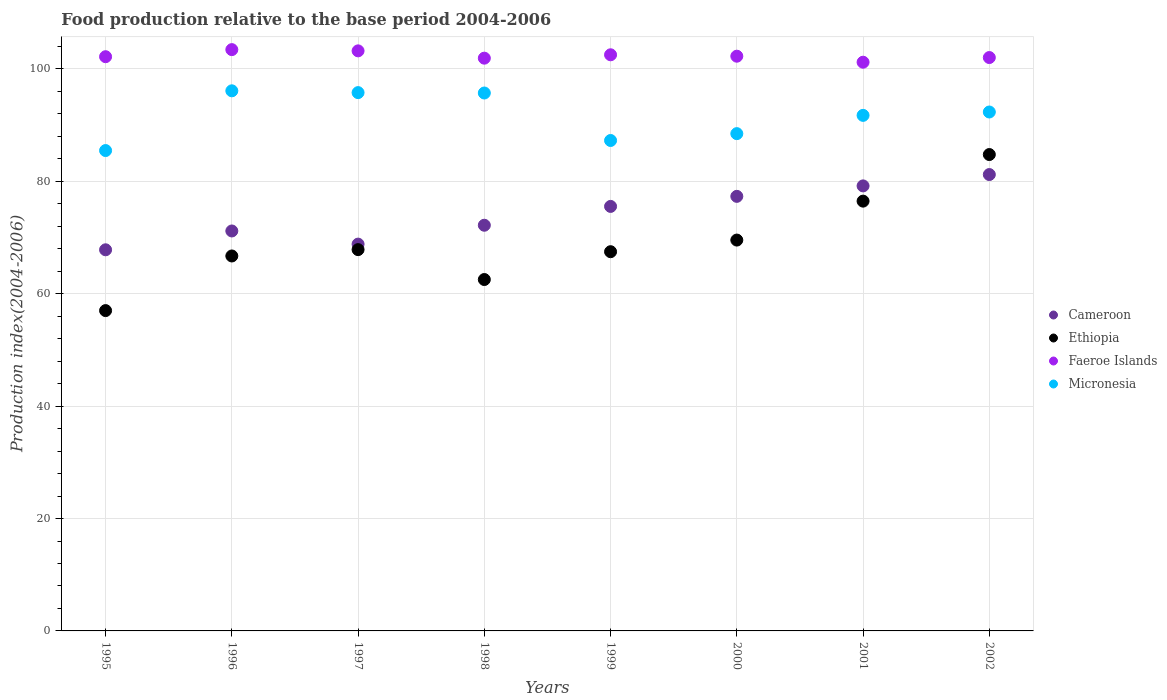Is the number of dotlines equal to the number of legend labels?
Offer a very short reply. Yes. What is the food production index in Faeroe Islands in 2002?
Offer a very short reply. 102.03. Across all years, what is the maximum food production index in Micronesia?
Your response must be concise. 96.11. Across all years, what is the minimum food production index in Micronesia?
Ensure brevity in your answer.  85.48. In which year was the food production index in Micronesia maximum?
Provide a short and direct response. 1996. In which year was the food production index in Faeroe Islands minimum?
Your response must be concise. 2001. What is the total food production index in Faeroe Islands in the graph?
Make the answer very short. 818.78. What is the difference between the food production index in Faeroe Islands in 1995 and that in 1998?
Keep it short and to the point. 0.26. What is the difference between the food production index in Micronesia in 1999 and the food production index in Cameroon in 2000?
Your response must be concise. 9.94. What is the average food production index in Cameroon per year?
Keep it short and to the point. 74.16. In the year 1997, what is the difference between the food production index in Faeroe Islands and food production index in Cameroon?
Provide a succinct answer. 34.39. What is the ratio of the food production index in Cameroon in 1995 to that in 1999?
Your answer should be very brief. 0.9. Is the food production index in Ethiopia in 1998 less than that in 1999?
Your answer should be compact. Yes. Is the difference between the food production index in Faeroe Islands in 1995 and 2000 greater than the difference between the food production index in Cameroon in 1995 and 2000?
Your answer should be very brief. Yes. What is the difference between the highest and the second highest food production index in Faeroe Islands?
Provide a short and direct response. 0.22. What is the difference between the highest and the lowest food production index in Micronesia?
Offer a terse response. 10.63. In how many years, is the food production index in Faeroe Islands greater than the average food production index in Faeroe Islands taken over all years?
Offer a terse response. 3. Is the sum of the food production index in Ethiopia in 1999 and 2001 greater than the maximum food production index in Cameroon across all years?
Your answer should be very brief. Yes. Is it the case that in every year, the sum of the food production index in Micronesia and food production index in Faeroe Islands  is greater than the food production index in Ethiopia?
Offer a terse response. Yes. Does the food production index in Cameroon monotonically increase over the years?
Your answer should be compact. No. Is the food production index in Cameroon strictly less than the food production index in Ethiopia over the years?
Keep it short and to the point. No. Are the values on the major ticks of Y-axis written in scientific E-notation?
Offer a terse response. No. Does the graph contain grids?
Offer a terse response. Yes. How are the legend labels stacked?
Give a very brief answer. Vertical. What is the title of the graph?
Provide a succinct answer. Food production relative to the base period 2004-2006. What is the label or title of the Y-axis?
Provide a succinct answer. Production index(2004-2006). What is the Production index(2004-2006) of Cameroon in 1995?
Your answer should be compact. 67.82. What is the Production index(2004-2006) of Faeroe Islands in 1995?
Offer a very short reply. 102.18. What is the Production index(2004-2006) in Micronesia in 1995?
Offer a terse response. 85.48. What is the Production index(2004-2006) in Cameroon in 1996?
Make the answer very short. 71.17. What is the Production index(2004-2006) of Ethiopia in 1996?
Your answer should be very brief. 66.72. What is the Production index(2004-2006) of Faeroe Islands in 1996?
Give a very brief answer. 103.44. What is the Production index(2004-2006) in Micronesia in 1996?
Ensure brevity in your answer.  96.11. What is the Production index(2004-2006) in Cameroon in 1997?
Ensure brevity in your answer.  68.83. What is the Production index(2004-2006) in Ethiopia in 1997?
Provide a succinct answer. 67.85. What is the Production index(2004-2006) of Faeroe Islands in 1997?
Provide a short and direct response. 103.22. What is the Production index(2004-2006) in Micronesia in 1997?
Keep it short and to the point. 95.79. What is the Production index(2004-2006) of Cameroon in 1998?
Give a very brief answer. 72.19. What is the Production index(2004-2006) of Ethiopia in 1998?
Provide a short and direct response. 62.53. What is the Production index(2004-2006) of Faeroe Islands in 1998?
Make the answer very short. 101.92. What is the Production index(2004-2006) in Micronesia in 1998?
Provide a short and direct response. 95.72. What is the Production index(2004-2006) in Cameroon in 1999?
Make the answer very short. 75.54. What is the Production index(2004-2006) in Ethiopia in 1999?
Make the answer very short. 67.48. What is the Production index(2004-2006) in Faeroe Islands in 1999?
Your answer should be compact. 102.52. What is the Production index(2004-2006) of Micronesia in 1999?
Make the answer very short. 87.27. What is the Production index(2004-2006) in Cameroon in 2000?
Your response must be concise. 77.33. What is the Production index(2004-2006) in Ethiopia in 2000?
Keep it short and to the point. 69.55. What is the Production index(2004-2006) of Faeroe Islands in 2000?
Give a very brief answer. 102.27. What is the Production index(2004-2006) in Micronesia in 2000?
Offer a terse response. 88.49. What is the Production index(2004-2006) in Cameroon in 2001?
Make the answer very short. 79.19. What is the Production index(2004-2006) in Ethiopia in 2001?
Offer a terse response. 76.48. What is the Production index(2004-2006) in Faeroe Islands in 2001?
Provide a short and direct response. 101.2. What is the Production index(2004-2006) in Micronesia in 2001?
Your answer should be compact. 91.74. What is the Production index(2004-2006) in Cameroon in 2002?
Your answer should be compact. 81.21. What is the Production index(2004-2006) in Ethiopia in 2002?
Provide a succinct answer. 84.77. What is the Production index(2004-2006) in Faeroe Islands in 2002?
Provide a succinct answer. 102.03. What is the Production index(2004-2006) in Micronesia in 2002?
Your response must be concise. 92.34. Across all years, what is the maximum Production index(2004-2006) in Cameroon?
Make the answer very short. 81.21. Across all years, what is the maximum Production index(2004-2006) of Ethiopia?
Provide a short and direct response. 84.77. Across all years, what is the maximum Production index(2004-2006) in Faeroe Islands?
Provide a succinct answer. 103.44. Across all years, what is the maximum Production index(2004-2006) of Micronesia?
Provide a short and direct response. 96.11. Across all years, what is the minimum Production index(2004-2006) in Cameroon?
Your response must be concise. 67.82. Across all years, what is the minimum Production index(2004-2006) in Ethiopia?
Ensure brevity in your answer.  57. Across all years, what is the minimum Production index(2004-2006) in Faeroe Islands?
Provide a succinct answer. 101.2. Across all years, what is the minimum Production index(2004-2006) in Micronesia?
Your response must be concise. 85.48. What is the total Production index(2004-2006) of Cameroon in the graph?
Offer a terse response. 593.28. What is the total Production index(2004-2006) of Ethiopia in the graph?
Make the answer very short. 552.38. What is the total Production index(2004-2006) in Faeroe Islands in the graph?
Provide a short and direct response. 818.78. What is the total Production index(2004-2006) of Micronesia in the graph?
Keep it short and to the point. 732.94. What is the difference between the Production index(2004-2006) in Cameroon in 1995 and that in 1996?
Your answer should be very brief. -3.35. What is the difference between the Production index(2004-2006) of Ethiopia in 1995 and that in 1996?
Your answer should be compact. -9.72. What is the difference between the Production index(2004-2006) in Faeroe Islands in 1995 and that in 1996?
Provide a succinct answer. -1.26. What is the difference between the Production index(2004-2006) of Micronesia in 1995 and that in 1996?
Provide a succinct answer. -10.63. What is the difference between the Production index(2004-2006) in Cameroon in 1995 and that in 1997?
Offer a very short reply. -1.01. What is the difference between the Production index(2004-2006) of Ethiopia in 1995 and that in 1997?
Give a very brief answer. -10.85. What is the difference between the Production index(2004-2006) in Faeroe Islands in 1995 and that in 1997?
Your response must be concise. -1.04. What is the difference between the Production index(2004-2006) in Micronesia in 1995 and that in 1997?
Offer a very short reply. -10.31. What is the difference between the Production index(2004-2006) of Cameroon in 1995 and that in 1998?
Ensure brevity in your answer.  -4.37. What is the difference between the Production index(2004-2006) of Ethiopia in 1995 and that in 1998?
Your response must be concise. -5.53. What is the difference between the Production index(2004-2006) of Faeroe Islands in 1995 and that in 1998?
Give a very brief answer. 0.26. What is the difference between the Production index(2004-2006) of Micronesia in 1995 and that in 1998?
Your answer should be very brief. -10.24. What is the difference between the Production index(2004-2006) in Cameroon in 1995 and that in 1999?
Offer a very short reply. -7.72. What is the difference between the Production index(2004-2006) in Ethiopia in 1995 and that in 1999?
Your answer should be very brief. -10.48. What is the difference between the Production index(2004-2006) of Faeroe Islands in 1995 and that in 1999?
Offer a very short reply. -0.34. What is the difference between the Production index(2004-2006) in Micronesia in 1995 and that in 1999?
Offer a terse response. -1.79. What is the difference between the Production index(2004-2006) in Cameroon in 1995 and that in 2000?
Offer a very short reply. -9.51. What is the difference between the Production index(2004-2006) of Ethiopia in 1995 and that in 2000?
Offer a very short reply. -12.55. What is the difference between the Production index(2004-2006) in Faeroe Islands in 1995 and that in 2000?
Ensure brevity in your answer.  -0.09. What is the difference between the Production index(2004-2006) in Micronesia in 1995 and that in 2000?
Your answer should be very brief. -3.01. What is the difference between the Production index(2004-2006) of Cameroon in 1995 and that in 2001?
Your answer should be compact. -11.37. What is the difference between the Production index(2004-2006) of Ethiopia in 1995 and that in 2001?
Provide a short and direct response. -19.48. What is the difference between the Production index(2004-2006) of Micronesia in 1995 and that in 2001?
Your answer should be very brief. -6.26. What is the difference between the Production index(2004-2006) of Cameroon in 1995 and that in 2002?
Keep it short and to the point. -13.39. What is the difference between the Production index(2004-2006) of Ethiopia in 1995 and that in 2002?
Your answer should be very brief. -27.77. What is the difference between the Production index(2004-2006) of Faeroe Islands in 1995 and that in 2002?
Your response must be concise. 0.15. What is the difference between the Production index(2004-2006) in Micronesia in 1995 and that in 2002?
Make the answer very short. -6.86. What is the difference between the Production index(2004-2006) in Cameroon in 1996 and that in 1997?
Your answer should be very brief. 2.34. What is the difference between the Production index(2004-2006) in Ethiopia in 1996 and that in 1997?
Make the answer very short. -1.13. What is the difference between the Production index(2004-2006) in Faeroe Islands in 1996 and that in 1997?
Ensure brevity in your answer.  0.22. What is the difference between the Production index(2004-2006) of Micronesia in 1996 and that in 1997?
Offer a very short reply. 0.32. What is the difference between the Production index(2004-2006) of Cameroon in 1996 and that in 1998?
Offer a very short reply. -1.02. What is the difference between the Production index(2004-2006) of Ethiopia in 1996 and that in 1998?
Offer a very short reply. 4.19. What is the difference between the Production index(2004-2006) of Faeroe Islands in 1996 and that in 1998?
Ensure brevity in your answer.  1.52. What is the difference between the Production index(2004-2006) of Micronesia in 1996 and that in 1998?
Your answer should be compact. 0.39. What is the difference between the Production index(2004-2006) of Cameroon in 1996 and that in 1999?
Your answer should be very brief. -4.37. What is the difference between the Production index(2004-2006) of Ethiopia in 1996 and that in 1999?
Offer a very short reply. -0.76. What is the difference between the Production index(2004-2006) in Faeroe Islands in 1996 and that in 1999?
Your answer should be very brief. 0.92. What is the difference between the Production index(2004-2006) of Micronesia in 1996 and that in 1999?
Give a very brief answer. 8.84. What is the difference between the Production index(2004-2006) in Cameroon in 1996 and that in 2000?
Provide a short and direct response. -6.16. What is the difference between the Production index(2004-2006) of Ethiopia in 1996 and that in 2000?
Give a very brief answer. -2.83. What is the difference between the Production index(2004-2006) in Faeroe Islands in 1996 and that in 2000?
Keep it short and to the point. 1.17. What is the difference between the Production index(2004-2006) in Micronesia in 1996 and that in 2000?
Your answer should be compact. 7.62. What is the difference between the Production index(2004-2006) of Cameroon in 1996 and that in 2001?
Your answer should be very brief. -8.02. What is the difference between the Production index(2004-2006) of Ethiopia in 1996 and that in 2001?
Make the answer very short. -9.76. What is the difference between the Production index(2004-2006) in Faeroe Islands in 1996 and that in 2001?
Give a very brief answer. 2.24. What is the difference between the Production index(2004-2006) of Micronesia in 1996 and that in 2001?
Keep it short and to the point. 4.37. What is the difference between the Production index(2004-2006) of Cameroon in 1996 and that in 2002?
Your response must be concise. -10.04. What is the difference between the Production index(2004-2006) of Ethiopia in 1996 and that in 2002?
Your answer should be compact. -18.05. What is the difference between the Production index(2004-2006) in Faeroe Islands in 1996 and that in 2002?
Ensure brevity in your answer.  1.41. What is the difference between the Production index(2004-2006) of Micronesia in 1996 and that in 2002?
Offer a terse response. 3.77. What is the difference between the Production index(2004-2006) in Cameroon in 1997 and that in 1998?
Give a very brief answer. -3.36. What is the difference between the Production index(2004-2006) in Ethiopia in 1997 and that in 1998?
Offer a terse response. 5.32. What is the difference between the Production index(2004-2006) of Faeroe Islands in 1997 and that in 1998?
Your response must be concise. 1.3. What is the difference between the Production index(2004-2006) of Micronesia in 1997 and that in 1998?
Provide a short and direct response. 0.07. What is the difference between the Production index(2004-2006) of Cameroon in 1997 and that in 1999?
Your answer should be compact. -6.71. What is the difference between the Production index(2004-2006) of Ethiopia in 1997 and that in 1999?
Provide a short and direct response. 0.37. What is the difference between the Production index(2004-2006) in Micronesia in 1997 and that in 1999?
Provide a short and direct response. 8.52. What is the difference between the Production index(2004-2006) of Cameroon in 1997 and that in 2000?
Provide a short and direct response. -8.5. What is the difference between the Production index(2004-2006) of Cameroon in 1997 and that in 2001?
Your response must be concise. -10.36. What is the difference between the Production index(2004-2006) in Ethiopia in 1997 and that in 2001?
Make the answer very short. -8.63. What is the difference between the Production index(2004-2006) in Faeroe Islands in 1997 and that in 2001?
Provide a succinct answer. 2.02. What is the difference between the Production index(2004-2006) of Micronesia in 1997 and that in 2001?
Provide a short and direct response. 4.05. What is the difference between the Production index(2004-2006) of Cameroon in 1997 and that in 2002?
Offer a very short reply. -12.38. What is the difference between the Production index(2004-2006) in Ethiopia in 1997 and that in 2002?
Provide a short and direct response. -16.92. What is the difference between the Production index(2004-2006) of Faeroe Islands in 1997 and that in 2002?
Your answer should be compact. 1.19. What is the difference between the Production index(2004-2006) of Micronesia in 1997 and that in 2002?
Your response must be concise. 3.45. What is the difference between the Production index(2004-2006) of Cameroon in 1998 and that in 1999?
Offer a terse response. -3.35. What is the difference between the Production index(2004-2006) of Ethiopia in 1998 and that in 1999?
Your answer should be very brief. -4.95. What is the difference between the Production index(2004-2006) in Micronesia in 1998 and that in 1999?
Ensure brevity in your answer.  8.45. What is the difference between the Production index(2004-2006) in Cameroon in 1998 and that in 2000?
Your response must be concise. -5.14. What is the difference between the Production index(2004-2006) in Ethiopia in 1998 and that in 2000?
Provide a short and direct response. -7.02. What is the difference between the Production index(2004-2006) of Faeroe Islands in 1998 and that in 2000?
Give a very brief answer. -0.35. What is the difference between the Production index(2004-2006) of Micronesia in 1998 and that in 2000?
Your answer should be compact. 7.23. What is the difference between the Production index(2004-2006) of Ethiopia in 1998 and that in 2001?
Offer a very short reply. -13.95. What is the difference between the Production index(2004-2006) of Faeroe Islands in 1998 and that in 2001?
Your answer should be compact. 0.72. What is the difference between the Production index(2004-2006) of Micronesia in 1998 and that in 2001?
Keep it short and to the point. 3.98. What is the difference between the Production index(2004-2006) in Cameroon in 1998 and that in 2002?
Give a very brief answer. -9.02. What is the difference between the Production index(2004-2006) in Ethiopia in 1998 and that in 2002?
Offer a very short reply. -22.24. What is the difference between the Production index(2004-2006) of Faeroe Islands in 1998 and that in 2002?
Make the answer very short. -0.11. What is the difference between the Production index(2004-2006) in Micronesia in 1998 and that in 2002?
Provide a succinct answer. 3.38. What is the difference between the Production index(2004-2006) in Cameroon in 1999 and that in 2000?
Offer a terse response. -1.79. What is the difference between the Production index(2004-2006) of Ethiopia in 1999 and that in 2000?
Provide a short and direct response. -2.07. What is the difference between the Production index(2004-2006) of Faeroe Islands in 1999 and that in 2000?
Offer a terse response. 0.25. What is the difference between the Production index(2004-2006) of Micronesia in 1999 and that in 2000?
Provide a short and direct response. -1.22. What is the difference between the Production index(2004-2006) in Cameroon in 1999 and that in 2001?
Provide a short and direct response. -3.65. What is the difference between the Production index(2004-2006) of Faeroe Islands in 1999 and that in 2001?
Ensure brevity in your answer.  1.32. What is the difference between the Production index(2004-2006) in Micronesia in 1999 and that in 2001?
Make the answer very short. -4.47. What is the difference between the Production index(2004-2006) of Cameroon in 1999 and that in 2002?
Ensure brevity in your answer.  -5.67. What is the difference between the Production index(2004-2006) of Ethiopia in 1999 and that in 2002?
Ensure brevity in your answer.  -17.29. What is the difference between the Production index(2004-2006) in Faeroe Islands in 1999 and that in 2002?
Give a very brief answer. 0.49. What is the difference between the Production index(2004-2006) of Micronesia in 1999 and that in 2002?
Give a very brief answer. -5.07. What is the difference between the Production index(2004-2006) in Cameroon in 2000 and that in 2001?
Ensure brevity in your answer.  -1.86. What is the difference between the Production index(2004-2006) of Ethiopia in 2000 and that in 2001?
Offer a very short reply. -6.93. What is the difference between the Production index(2004-2006) of Faeroe Islands in 2000 and that in 2001?
Ensure brevity in your answer.  1.07. What is the difference between the Production index(2004-2006) in Micronesia in 2000 and that in 2001?
Offer a terse response. -3.25. What is the difference between the Production index(2004-2006) of Cameroon in 2000 and that in 2002?
Ensure brevity in your answer.  -3.88. What is the difference between the Production index(2004-2006) of Ethiopia in 2000 and that in 2002?
Provide a succinct answer. -15.22. What is the difference between the Production index(2004-2006) of Faeroe Islands in 2000 and that in 2002?
Your answer should be very brief. 0.24. What is the difference between the Production index(2004-2006) in Micronesia in 2000 and that in 2002?
Offer a terse response. -3.85. What is the difference between the Production index(2004-2006) in Cameroon in 2001 and that in 2002?
Offer a terse response. -2.02. What is the difference between the Production index(2004-2006) of Ethiopia in 2001 and that in 2002?
Your response must be concise. -8.29. What is the difference between the Production index(2004-2006) in Faeroe Islands in 2001 and that in 2002?
Keep it short and to the point. -0.83. What is the difference between the Production index(2004-2006) in Micronesia in 2001 and that in 2002?
Provide a short and direct response. -0.6. What is the difference between the Production index(2004-2006) of Cameroon in 1995 and the Production index(2004-2006) of Ethiopia in 1996?
Keep it short and to the point. 1.1. What is the difference between the Production index(2004-2006) of Cameroon in 1995 and the Production index(2004-2006) of Faeroe Islands in 1996?
Give a very brief answer. -35.62. What is the difference between the Production index(2004-2006) in Cameroon in 1995 and the Production index(2004-2006) in Micronesia in 1996?
Your response must be concise. -28.29. What is the difference between the Production index(2004-2006) in Ethiopia in 1995 and the Production index(2004-2006) in Faeroe Islands in 1996?
Make the answer very short. -46.44. What is the difference between the Production index(2004-2006) in Ethiopia in 1995 and the Production index(2004-2006) in Micronesia in 1996?
Offer a very short reply. -39.11. What is the difference between the Production index(2004-2006) in Faeroe Islands in 1995 and the Production index(2004-2006) in Micronesia in 1996?
Your answer should be very brief. 6.07. What is the difference between the Production index(2004-2006) in Cameroon in 1995 and the Production index(2004-2006) in Ethiopia in 1997?
Offer a terse response. -0.03. What is the difference between the Production index(2004-2006) of Cameroon in 1995 and the Production index(2004-2006) of Faeroe Islands in 1997?
Provide a succinct answer. -35.4. What is the difference between the Production index(2004-2006) in Cameroon in 1995 and the Production index(2004-2006) in Micronesia in 1997?
Give a very brief answer. -27.97. What is the difference between the Production index(2004-2006) of Ethiopia in 1995 and the Production index(2004-2006) of Faeroe Islands in 1997?
Ensure brevity in your answer.  -46.22. What is the difference between the Production index(2004-2006) in Ethiopia in 1995 and the Production index(2004-2006) in Micronesia in 1997?
Provide a short and direct response. -38.79. What is the difference between the Production index(2004-2006) of Faeroe Islands in 1995 and the Production index(2004-2006) of Micronesia in 1997?
Ensure brevity in your answer.  6.39. What is the difference between the Production index(2004-2006) of Cameroon in 1995 and the Production index(2004-2006) of Ethiopia in 1998?
Offer a terse response. 5.29. What is the difference between the Production index(2004-2006) in Cameroon in 1995 and the Production index(2004-2006) in Faeroe Islands in 1998?
Offer a very short reply. -34.1. What is the difference between the Production index(2004-2006) in Cameroon in 1995 and the Production index(2004-2006) in Micronesia in 1998?
Your answer should be compact. -27.9. What is the difference between the Production index(2004-2006) in Ethiopia in 1995 and the Production index(2004-2006) in Faeroe Islands in 1998?
Give a very brief answer. -44.92. What is the difference between the Production index(2004-2006) in Ethiopia in 1995 and the Production index(2004-2006) in Micronesia in 1998?
Offer a terse response. -38.72. What is the difference between the Production index(2004-2006) of Faeroe Islands in 1995 and the Production index(2004-2006) of Micronesia in 1998?
Your answer should be very brief. 6.46. What is the difference between the Production index(2004-2006) of Cameroon in 1995 and the Production index(2004-2006) of Ethiopia in 1999?
Keep it short and to the point. 0.34. What is the difference between the Production index(2004-2006) of Cameroon in 1995 and the Production index(2004-2006) of Faeroe Islands in 1999?
Offer a very short reply. -34.7. What is the difference between the Production index(2004-2006) of Cameroon in 1995 and the Production index(2004-2006) of Micronesia in 1999?
Keep it short and to the point. -19.45. What is the difference between the Production index(2004-2006) of Ethiopia in 1995 and the Production index(2004-2006) of Faeroe Islands in 1999?
Offer a terse response. -45.52. What is the difference between the Production index(2004-2006) of Ethiopia in 1995 and the Production index(2004-2006) of Micronesia in 1999?
Your response must be concise. -30.27. What is the difference between the Production index(2004-2006) in Faeroe Islands in 1995 and the Production index(2004-2006) in Micronesia in 1999?
Your answer should be very brief. 14.91. What is the difference between the Production index(2004-2006) of Cameroon in 1995 and the Production index(2004-2006) of Ethiopia in 2000?
Give a very brief answer. -1.73. What is the difference between the Production index(2004-2006) in Cameroon in 1995 and the Production index(2004-2006) in Faeroe Islands in 2000?
Keep it short and to the point. -34.45. What is the difference between the Production index(2004-2006) of Cameroon in 1995 and the Production index(2004-2006) of Micronesia in 2000?
Keep it short and to the point. -20.67. What is the difference between the Production index(2004-2006) in Ethiopia in 1995 and the Production index(2004-2006) in Faeroe Islands in 2000?
Your answer should be very brief. -45.27. What is the difference between the Production index(2004-2006) in Ethiopia in 1995 and the Production index(2004-2006) in Micronesia in 2000?
Your answer should be compact. -31.49. What is the difference between the Production index(2004-2006) of Faeroe Islands in 1995 and the Production index(2004-2006) of Micronesia in 2000?
Your answer should be compact. 13.69. What is the difference between the Production index(2004-2006) in Cameroon in 1995 and the Production index(2004-2006) in Ethiopia in 2001?
Offer a very short reply. -8.66. What is the difference between the Production index(2004-2006) of Cameroon in 1995 and the Production index(2004-2006) of Faeroe Islands in 2001?
Your answer should be compact. -33.38. What is the difference between the Production index(2004-2006) of Cameroon in 1995 and the Production index(2004-2006) of Micronesia in 2001?
Provide a short and direct response. -23.92. What is the difference between the Production index(2004-2006) of Ethiopia in 1995 and the Production index(2004-2006) of Faeroe Islands in 2001?
Your answer should be compact. -44.2. What is the difference between the Production index(2004-2006) of Ethiopia in 1995 and the Production index(2004-2006) of Micronesia in 2001?
Your answer should be very brief. -34.74. What is the difference between the Production index(2004-2006) in Faeroe Islands in 1995 and the Production index(2004-2006) in Micronesia in 2001?
Keep it short and to the point. 10.44. What is the difference between the Production index(2004-2006) in Cameroon in 1995 and the Production index(2004-2006) in Ethiopia in 2002?
Give a very brief answer. -16.95. What is the difference between the Production index(2004-2006) of Cameroon in 1995 and the Production index(2004-2006) of Faeroe Islands in 2002?
Your answer should be very brief. -34.21. What is the difference between the Production index(2004-2006) of Cameroon in 1995 and the Production index(2004-2006) of Micronesia in 2002?
Your answer should be very brief. -24.52. What is the difference between the Production index(2004-2006) of Ethiopia in 1995 and the Production index(2004-2006) of Faeroe Islands in 2002?
Provide a succinct answer. -45.03. What is the difference between the Production index(2004-2006) of Ethiopia in 1995 and the Production index(2004-2006) of Micronesia in 2002?
Provide a succinct answer. -35.34. What is the difference between the Production index(2004-2006) of Faeroe Islands in 1995 and the Production index(2004-2006) of Micronesia in 2002?
Your response must be concise. 9.84. What is the difference between the Production index(2004-2006) of Cameroon in 1996 and the Production index(2004-2006) of Ethiopia in 1997?
Offer a terse response. 3.32. What is the difference between the Production index(2004-2006) of Cameroon in 1996 and the Production index(2004-2006) of Faeroe Islands in 1997?
Offer a very short reply. -32.05. What is the difference between the Production index(2004-2006) in Cameroon in 1996 and the Production index(2004-2006) in Micronesia in 1997?
Provide a short and direct response. -24.62. What is the difference between the Production index(2004-2006) in Ethiopia in 1996 and the Production index(2004-2006) in Faeroe Islands in 1997?
Provide a short and direct response. -36.5. What is the difference between the Production index(2004-2006) of Ethiopia in 1996 and the Production index(2004-2006) of Micronesia in 1997?
Offer a terse response. -29.07. What is the difference between the Production index(2004-2006) of Faeroe Islands in 1996 and the Production index(2004-2006) of Micronesia in 1997?
Provide a short and direct response. 7.65. What is the difference between the Production index(2004-2006) of Cameroon in 1996 and the Production index(2004-2006) of Ethiopia in 1998?
Give a very brief answer. 8.64. What is the difference between the Production index(2004-2006) in Cameroon in 1996 and the Production index(2004-2006) in Faeroe Islands in 1998?
Make the answer very short. -30.75. What is the difference between the Production index(2004-2006) in Cameroon in 1996 and the Production index(2004-2006) in Micronesia in 1998?
Your answer should be compact. -24.55. What is the difference between the Production index(2004-2006) of Ethiopia in 1996 and the Production index(2004-2006) of Faeroe Islands in 1998?
Offer a terse response. -35.2. What is the difference between the Production index(2004-2006) in Ethiopia in 1996 and the Production index(2004-2006) in Micronesia in 1998?
Provide a succinct answer. -29. What is the difference between the Production index(2004-2006) in Faeroe Islands in 1996 and the Production index(2004-2006) in Micronesia in 1998?
Provide a succinct answer. 7.72. What is the difference between the Production index(2004-2006) of Cameroon in 1996 and the Production index(2004-2006) of Ethiopia in 1999?
Offer a very short reply. 3.69. What is the difference between the Production index(2004-2006) of Cameroon in 1996 and the Production index(2004-2006) of Faeroe Islands in 1999?
Your answer should be compact. -31.35. What is the difference between the Production index(2004-2006) of Cameroon in 1996 and the Production index(2004-2006) of Micronesia in 1999?
Offer a terse response. -16.1. What is the difference between the Production index(2004-2006) in Ethiopia in 1996 and the Production index(2004-2006) in Faeroe Islands in 1999?
Provide a short and direct response. -35.8. What is the difference between the Production index(2004-2006) in Ethiopia in 1996 and the Production index(2004-2006) in Micronesia in 1999?
Provide a short and direct response. -20.55. What is the difference between the Production index(2004-2006) in Faeroe Islands in 1996 and the Production index(2004-2006) in Micronesia in 1999?
Your response must be concise. 16.17. What is the difference between the Production index(2004-2006) in Cameroon in 1996 and the Production index(2004-2006) in Ethiopia in 2000?
Give a very brief answer. 1.62. What is the difference between the Production index(2004-2006) of Cameroon in 1996 and the Production index(2004-2006) of Faeroe Islands in 2000?
Offer a terse response. -31.1. What is the difference between the Production index(2004-2006) of Cameroon in 1996 and the Production index(2004-2006) of Micronesia in 2000?
Give a very brief answer. -17.32. What is the difference between the Production index(2004-2006) of Ethiopia in 1996 and the Production index(2004-2006) of Faeroe Islands in 2000?
Provide a short and direct response. -35.55. What is the difference between the Production index(2004-2006) of Ethiopia in 1996 and the Production index(2004-2006) of Micronesia in 2000?
Provide a succinct answer. -21.77. What is the difference between the Production index(2004-2006) of Faeroe Islands in 1996 and the Production index(2004-2006) of Micronesia in 2000?
Provide a short and direct response. 14.95. What is the difference between the Production index(2004-2006) in Cameroon in 1996 and the Production index(2004-2006) in Ethiopia in 2001?
Your answer should be compact. -5.31. What is the difference between the Production index(2004-2006) in Cameroon in 1996 and the Production index(2004-2006) in Faeroe Islands in 2001?
Your answer should be very brief. -30.03. What is the difference between the Production index(2004-2006) of Cameroon in 1996 and the Production index(2004-2006) of Micronesia in 2001?
Your answer should be very brief. -20.57. What is the difference between the Production index(2004-2006) of Ethiopia in 1996 and the Production index(2004-2006) of Faeroe Islands in 2001?
Offer a terse response. -34.48. What is the difference between the Production index(2004-2006) of Ethiopia in 1996 and the Production index(2004-2006) of Micronesia in 2001?
Provide a succinct answer. -25.02. What is the difference between the Production index(2004-2006) in Cameroon in 1996 and the Production index(2004-2006) in Faeroe Islands in 2002?
Offer a very short reply. -30.86. What is the difference between the Production index(2004-2006) of Cameroon in 1996 and the Production index(2004-2006) of Micronesia in 2002?
Your answer should be compact. -21.17. What is the difference between the Production index(2004-2006) of Ethiopia in 1996 and the Production index(2004-2006) of Faeroe Islands in 2002?
Your answer should be very brief. -35.31. What is the difference between the Production index(2004-2006) of Ethiopia in 1996 and the Production index(2004-2006) of Micronesia in 2002?
Ensure brevity in your answer.  -25.62. What is the difference between the Production index(2004-2006) of Cameroon in 1997 and the Production index(2004-2006) of Faeroe Islands in 1998?
Ensure brevity in your answer.  -33.09. What is the difference between the Production index(2004-2006) of Cameroon in 1997 and the Production index(2004-2006) of Micronesia in 1998?
Keep it short and to the point. -26.89. What is the difference between the Production index(2004-2006) of Ethiopia in 1997 and the Production index(2004-2006) of Faeroe Islands in 1998?
Make the answer very short. -34.07. What is the difference between the Production index(2004-2006) in Ethiopia in 1997 and the Production index(2004-2006) in Micronesia in 1998?
Offer a terse response. -27.87. What is the difference between the Production index(2004-2006) of Faeroe Islands in 1997 and the Production index(2004-2006) of Micronesia in 1998?
Provide a succinct answer. 7.5. What is the difference between the Production index(2004-2006) in Cameroon in 1997 and the Production index(2004-2006) in Ethiopia in 1999?
Offer a very short reply. 1.35. What is the difference between the Production index(2004-2006) of Cameroon in 1997 and the Production index(2004-2006) of Faeroe Islands in 1999?
Make the answer very short. -33.69. What is the difference between the Production index(2004-2006) of Cameroon in 1997 and the Production index(2004-2006) of Micronesia in 1999?
Ensure brevity in your answer.  -18.44. What is the difference between the Production index(2004-2006) of Ethiopia in 1997 and the Production index(2004-2006) of Faeroe Islands in 1999?
Your answer should be compact. -34.67. What is the difference between the Production index(2004-2006) of Ethiopia in 1997 and the Production index(2004-2006) of Micronesia in 1999?
Offer a very short reply. -19.42. What is the difference between the Production index(2004-2006) in Faeroe Islands in 1997 and the Production index(2004-2006) in Micronesia in 1999?
Offer a very short reply. 15.95. What is the difference between the Production index(2004-2006) in Cameroon in 1997 and the Production index(2004-2006) in Ethiopia in 2000?
Ensure brevity in your answer.  -0.72. What is the difference between the Production index(2004-2006) in Cameroon in 1997 and the Production index(2004-2006) in Faeroe Islands in 2000?
Make the answer very short. -33.44. What is the difference between the Production index(2004-2006) in Cameroon in 1997 and the Production index(2004-2006) in Micronesia in 2000?
Ensure brevity in your answer.  -19.66. What is the difference between the Production index(2004-2006) in Ethiopia in 1997 and the Production index(2004-2006) in Faeroe Islands in 2000?
Give a very brief answer. -34.42. What is the difference between the Production index(2004-2006) in Ethiopia in 1997 and the Production index(2004-2006) in Micronesia in 2000?
Give a very brief answer. -20.64. What is the difference between the Production index(2004-2006) of Faeroe Islands in 1997 and the Production index(2004-2006) of Micronesia in 2000?
Your answer should be compact. 14.73. What is the difference between the Production index(2004-2006) in Cameroon in 1997 and the Production index(2004-2006) in Ethiopia in 2001?
Make the answer very short. -7.65. What is the difference between the Production index(2004-2006) in Cameroon in 1997 and the Production index(2004-2006) in Faeroe Islands in 2001?
Your response must be concise. -32.37. What is the difference between the Production index(2004-2006) of Cameroon in 1997 and the Production index(2004-2006) of Micronesia in 2001?
Provide a short and direct response. -22.91. What is the difference between the Production index(2004-2006) in Ethiopia in 1997 and the Production index(2004-2006) in Faeroe Islands in 2001?
Ensure brevity in your answer.  -33.35. What is the difference between the Production index(2004-2006) of Ethiopia in 1997 and the Production index(2004-2006) of Micronesia in 2001?
Your answer should be compact. -23.89. What is the difference between the Production index(2004-2006) of Faeroe Islands in 1997 and the Production index(2004-2006) of Micronesia in 2001?
Your answer should be very brief. 11.48. What is the difference between the Production index(2004-2006) in Cameroon in 1997 and the Production index(2004-2006) in Ethiopia in 2002?
Provide a short and direct response. -15.94. What is the difference between the Production index(2004-2006) in Cameroon in 1997 and the Production index(2004-2006) in Faeroe Islands in 2002?
Ensure brevity in your answer.  -33.2. What is the difference between the Production index(2004-2006) in Cameroon in 1997 and the Production index(2004-2006) in Micronesia in 2002?
Give a very brief answer. -23.51. What is the difference between the Production index(2004-2006) of Ethiopia in 1997 and the Production index(2004-2006) of Faeroe Islands in 2002?
Offer a terse response. -34.18. What is the difference between the Production index(2004-2006) of Ethiopia in 1997 and the Production index(2004-2006) of Micronesia in 2002?
Offer a very short reply. -24.49. What is the difference between the Production index(2004-2006) of Faeroe Islands in 1997 and the Production index(2004-2006) of Micronesia in 2002?
Make the answer very short. 10.88. What is the difference between the Production index(2004-2006) in Cameroon in 1998 and the Production index(2004-2006) in Ethiopia in 1999?
Make the answer very short. 4.71. What is the difference between the Production index(2004-2006) of Cameroon in 1998 and the Production index(2004-2006) of Faeroe Islands in 1999?
Your answer should be very brief. -30.33. What is the difference between the Production index(2004-2006) of Cameroon in 1998 and the Production index(2004-2006) of Micronesia in 1999?
Make the answer very short. -15.08. What is the difference between the Production index(2004-2006) in Ethiopia in 1998 and the Production index(2004-2006) in Faeroe Islands in 1999?
Ensure brevity in your answer.  -39.99. What is the difference between the Production index(2004-2006) in Ethiopia in 1998 and the Production index(2004-2006) in Micronesia in 1999?
Your answer should be compact. -24.74. What is the difference between the Production index(2004-2006) in Faeroe Islands in 1998 and the Production index(2004-2006) in Micronesia in 1999?
Your response must be concise. 14.65. What is the difference between the Production index(2004-2006) in Cameroon in 1998 and the Production index(2004-2006) in Ethiopia in 2000?
Ensure brevity in your answer.  2.64. What is the difference between the Production index(2004-2006) of Cameroon in 1998 and the Production index(2004-2006) of Faeroe Islands in 2000?
Your answer should be very brief. -30.08. What is the difference between the Production index(2004-2006) of Cameroon in 1998 and the Production index(2004-2006) of Micronesia in 2000?
Your answer should be very brief. -16.3. What is the difference between the Production index(2004-2006) of Ethiopia in 1998 and the Production index(2004-2006) of Faeroe Islands in 2000?
Ensure brevity in your answer.  -39.74. What is the difference between the Production index(2004-2006) in Ethiopia in 1998 and the Production index(2004-2006) in Micronesia in 2000?
Your response must be concise. -25.96. What is the difference between the Production index(2004-2006) in Faeroe Islands in 1998 and the Production index(2004-2006) in Micronesia in 2000?
Ensure brevity in your answer.  13.43. What is the difference between the Production index(2004-2006) in Cameroon in 1998 and the Production index(2004-2006) in Ethiopia in 2001?
Your answer should be very brief. -4.29. What is the difference between the Production index(2004-2006) of Cameroon in 1998 and the Production index(2004-2006) of Faeroe Islands in 2001?
Ensure brevity in your answer.  -29.01. What is the difference between the Production index(2004-2006) in Cameroon in 1998 and the Production index(2004-2006) in Micronesia in 2001?
Provide a succinct answer. -19.55. What is the difference between the Production index(2004-2006) in Ethiopia in 1998 and the Production index(2004-2006) in Faeroe Islands in 2001?
Provide a succinct answer. -38.67. What is the difference between the Production index(2004-2006) of Ethiopia in 1998 and the Production index(2004-2006) of Micronesia in 2001?
Provide a short and direct response. -29.21. What is the difference between the Production index(2004-2006) of Faeroe Islands in 1998 and the Production index(2004-2006) of Micronesia in 2001?
Offer a very short reply. 10.18. What is the difference between the Production index(2004-2006) of Cameroon in 1998 and the Production index(2004-2006) of Ethiopia in 2002?
Offer a very short reply. -12.58. What is the difference between the Production index(2004-2006) in Cameroon in 1998 and the Production index(2004-2006) in Faeroe Islands in 2002?
Ensure brevity in your answer.  -29.84. What is the difference between the Production index(2004-2006) of Cameroon in 1998 and the Production index(2004-2006) of Micronesia in 2002?
Your response must be concise. -20.15. What is the difference between the Production index(2004-2006) in Ethiopia in 1998 and the Production index(2004-2006) in Faeroe Islands in 2002?
Your answer should be very brief. -39.5. What is the difference between the Production index(2004-2006) in Ethiopia in 1998 and the Production index(2004-2006) in Micronesia in 2002?
Your answer should be very brief. -29.81. What is the difference between the Production index(2004-2006) of Faeroe Islands in 1998 and the Production index(2004-2006) of Micronesia in 2002?
Ensure brevity in your answer.  9.58. What is the difference between the Production index(2004-2006) of Cameroon in 1999 and the Production index(2004-2006) of Ethiopia in 2000?
Make the answer very short. 5.99. What is the difference between the Production index(2004-2006) of Cameroon in 1999 and the Production index(2004-2006) of Faeroe Islands in 2000?
Offer a terse response. -26.73. What is the difference between the Production index(2004-2006) in Cameroon in 1999 and the Production index(2004-2006) in Micronesia in 2000?
Your answer should be compact. -12.95. What is the difference between the Production index(2004-2006) of Ethiopia in 1999 and the Production index(2004-2006) of Faeroe Islands in 2000?
Keep it short and to the point. -34.79. What is the difference between the Production index(2004-2006) in Ethiopia in 1999 and the Production index(2004-2006) in Micronesia in 2000?
Your answer should be compact. -21.01. What is the difference between the Production index(2004-2006) in Faeroe Islands in 1999 and the Production index(2004-2006) in Micronesia in 2000?
Your answer should be very brief. 14.03. What is the difference between the Production index(2004-2006) of Cameroon in 1999 and the Production index(2004-2006) of Ethiopia in 2001?
Keep it short and to the point. -0.94. What is the difference between the Production index(2004-2006) in Cameroon in 1999 and the Production index(2004-2006) in Faeroe Islands in 2001?
Give a very brief answer. -25.66. What is the difference between the Production index(2004-2006) in Cameroon in 1999 and the Production index(2004-2006) in Micronesia in 2001?
Your response must be concise. -16.2. What is the difference between the Production index(2004-2006) in Ethiopia in 1999 and the Production index(2004-2006) in Faeroe Islands in 2001?
Your answer should be compact. -33.72. What is the difference between the Production index(2004-2006) in Ethiopia in 1999 and the Production index(2004-2006) in Micronesia in 2001?
Provide a succinct answer. -24.26. What is the difference between the Production index(2004-2006) of Faeroe Islands in 1999 and the Production index(2004-2006) of Micronesia in 2001?
Offer a terse response. 10.78. What is the difference between the Production index(2004-2006) of Cameroon in 1999 and the Production index(2004-2006) of Ethiopia in 2002?
Make the answer very short. -9.23. What is the difference between the Production index(2004-2006) of Cameroon in 1999 and the Production index(2004-2006) of Faeroe Islands in 2002?
Your answer should be very brief. -26.49. What is the difference between the Production index(2004-2006) in Cameroon in 1999 and the Production index(2004-2006) in Micronesia in 2002?
Offer a very short reply. -16.8. What is the difference between the Production index(2004-2006) of Ethiopia in 1999 and the Production index(2004-2006) of Faeroe Islands in 2002?
Your answer should be compact. -34.55. What is the difference between the Production index(2004-2006) of Ethiopia in 1999 and the Production index(2004-2006) of Micronesia in 2002?
Give a very brief answer. -24.86. What is the difference between the Production index(2004-2006) in Faeroe Islands in 1999 and the Production index(2004-2006) in Micronesia in 2002?
Provide a short and direct response. 10.18. What is the difference between the Production index(2004-2006) of Cameroon in 2000 and the Production index(2004-2006) of Ethiopia in 2001?
Give a very brief answer. 0.85. What is the difference between the Production index(2004-2006) of Cameroon in 2000 and the Production index(2004-2006) of Faeroe Islands in 2001?
Offer a very short reply. -23.87. What is the difference between the Production index(2004-2006) of Cameroon in 2000 and the Production index(2004-2006) of Micronesia in 2001?
Give a very brief answer. -14.41. What is the difference between the Production index(2004-2006) of Ethiopia in 2000 and the Production index(2004-2006) of Faeroe Islands in 2001?
Your response must be concise. -31.65. What is the difference between the Production index(2004-2006) in Ethiopia in 2000 and the Production index(2004-2006) in Micronesia in 2001?
Make the answer very short. -22.19. What is the difference between the Production index(2004-2006) of Faeroe Islands in 2000 and the Production index(2004-2006) of Micronesia in 2001?
Your answer should be very brief. 10.53. What is the difference between the Production index(2004-2006) of Cameroon in 2000 and the Production index(2004-2006) of Ethiopia in 2002?
Your answer should be compact. -7.44. What is the difference between the Production index(2004-2006) in Cameroon in 2000 and the Production index(2004-2006) in Faeroe Islands in 2002?
Keep it short and to the point. -24.7. What is the difference between the Production index(2004-2006) of Cameroon in 2000 and the Production index(2004-2006) of Micronesia in 2002?
Keep it short and to the point. -15.01. What is the difference between the Production index(2004-2006) in Ethiopia in 2000 and the Production index(2004-2006) in Faeroe Islands in 2002?
Your answer should be very brief. -32.48. What is the difference between the Production index(2004-2006) of Ethiopia in 2000 and the Production index(2004-2006) of Micronesia in 2002?
Your answer should be compact. -22.79. What is the difference between the Production index(2004-2006) of Faeroe Islands in 2000 and the Production index(2004-2006) of Micronesia in 2002?
Provide a short and direct response. 9.93. What is the difference between the Production index(2004-2006) in Cameroon in 2001 and the Production index(2004-2006) in Ethiopia in 2002?
Provide a short and direct response. -5.58. What is the difference between the Production index(2004-2006) in Cameroon in 2001 and the Production index(2004-2006) in Faeroe Islands in 2002?
Provide a short and direct response. -22.84. What is the difference between the Production index(2004-2006) in Cameroon in 2001 and the Production index(2004-2006) in Micronesia in 2002?
Offer a very short reply. -13.15. What is the difference between the Production index(2004-2006) of Ethiopia in 2001 and the Production index(2004-2006) of Faeroe Islands in 2002?
Make the answer very short. -25.55. What is the difference between the Production index(2004-2006) of Ethiopia in 2001 and the Production index(2004-2006) of Micronesia in 2002?
Offer a terse response. -15.86. What is the difference between the Production index(2004-2006) in Faeroe Islands in 2001 and the Production index(2004-2006) in Micronesia in 2002?
Your answer should be compact. 8.86. What is the average Production index(2004-2006) in Cameroon per year?
Offer a terse response. 74.16. What is the average Production index(2004-2006) of Ethiopia per year?
Provide a short and direct response. 69.05. What is the average Production index(2004-2006) of Faeroe Islands per year?
Give a very brief answer. 102.35. What is the average Production index(2004-2006) of Micronesia per year?
Make the answer very short. 91.62. In the year 1995, what is the difference between the Production index(2004-2006) in Cameroon and Production index(2004-2006) in Ethiopia?
Your answer should be very brief. 10.82. In the year 1995, what is the difference between the Production index(2004-2006) in Cameroon and Production index(2004-2006) in Faeroe Islands?
Provide a short and direct response. -34.36. In the year 1995, what is the difference between the Production index(2004-2006) of Cameroon and Production index(2004-2006) of Micronesia?
Your answer should be very brief. -17.66. In the year 1995, what is the difference between the Production index(2004-2006) of Ethiopia and Production index(2004-2006) of Faeroe Islands?
Provide a succinct answer. -45.18. In the year 1995, what is the difference between the Production index(2004-2006) in Ethiopia and Production index(2004-2006) in Micronesia?
Ensure brevity in your answer.  -28.48. In the year 1996, what is the difference between the Production index(2004-2006) of Cameroon and Production index(2004-2006) of Ethiopia?
Provide a short and direct response. 4.45. In the year 1996, what is the difference between the Production index(2004-2006) of Cameroon and Production index(2004-2006) of Faeroe Islands?
Give a very brief answer. -32.27. In the year 1996, what is the difference between the Production index(2004-2006) of Cameroon and Production index(2004-2006) of Micronesia?
Your response must be concise. -24.94. In the year 1996, what is the difference between the Production index(2004-2006) in Ethiopia and Production index(2004-2006) in Faeroe Islands?
Offer a very short reply. -36.72. In the year 1996, what is the difference between the Production index(2004-2006) in Ethiopia and Production index(2004-2006) in Micronesia?
Provide a succinct answer. -29.39. In the year 1996, what is the difference between the Production index(2004-2006) in Faeroe Islands and Production index(2004-2006) in Micronesia?
Offer a very short reply. 7.33. In the year 1997, what is the difference between the Production index(2004-2006) of Cameroon and Production index(2004-2006) of Ethiopia?
Make the answer very short. 0.98. In the year 1997, what is the difference between the Production index(2004-2006) of Cameroon and Production index(2004-2006) of Faeroe Islands?
Offer a very short reply. -34.39. In the year 1997, what is the difference between the Production index(2004-2006) in Cameroon and Production index(2004-2006) in Micronesia?
Give a very brief answer. -26.96. In the year 1997, what is the difference between the Production index(2004-2006) in Ethiopia and Production index(2004-2006) in Faeroe Islands?
Provide a short and direct response. -35.37. In the year 1997, what is the difference between the Production index(2004-2006) of Ethiopia and Production index(2004-2006) of Micronesia?
Ensure brevity in your answer.  -27.94. In the year 1997, what is the difference between the Production index(2004-2006) of Faeroe Islands and Production index(2004-2006) of Micronesia?
Ensure brevity in your answer.  7.43. In the year 1998, what is the difference between the Production index(2004-2006) in Cameroon and Production index(2004-2006) in Ethiopia?
Ensure brevity in your answer.  9.66. In the year 1998, what is the difference between the Production index(2004-2006) of Cameroon and Production index(2004-2006) of Faeroe Islands?
Offer a very short reply. -29.73. In the year 1998, what is the difference between the Production index(2004-2006) in Cameroon and Production index(2004-2006) in Micronesia?
Your response must be concise. -23.53. In the year 1998, what is the difference between the Production index(2004-2006) of Ethiopia and Production index(2004-2006) of Faeroe Islands?
Your answer should be compact. -39.39. In the year 1998, what is the difference between the Production index(2004-2006) of Ethiopia and Production index(2004-2006) of Micronesia?
Your answer should be very brief. -33.19. In the year 1998, what is the difference between the Production index(2004-2006) of Faeroe Islands and Production index(2004-2006) of Micronesia?
Provide a succinct answer. 6.2. In the year 1999, what is the difference between the Production index(2004-2006) of Cameroon and Production index(2004-2006) of Ethiopia?
Provide a succinct answer. 8.06. In the year 1999, what is the difference between the Production index(2004-2006) of Cameroon and Production index(2004-2006) of Faeroe Islands?
Provide a short and direct response. -26.98. In the year 1999, what is the difference between the Production index(2004-2006) of Cameroon and Production index(2004-2006) of Micronesia?
Ensure brevity in your answer.  -11.73. In the year 1999, what is the difference between the Production index(2004-2006) in Ethiopia and Production index(2004-2006) in Faeroe Islands?
Your answer should be compact. -35.04. In the year 1999, what is the difference between the Production index(2004-2006) in Ethiopia and Production index(2004-2006) in Micronesia?
Your response must be concise. -19.79. In the year 1999, what is the difference between the Production index(2004-2006) in Faeroe Islands and Production index(2004-2006) in Micronesia?
Offer a very short reply. 15.25. In the year 2000, what is the difference between the Production index(2004-2006) in Cameroon and Production index(2004-2006) in Ethiopia?
Your answer should be very brief. 7.78. In the year 2000, what is the difference between the Production index(2004-2006) of Cameroon and Production index(2004-2006) of Faeroe Islands?
Your response must be concise. -24.94. In the year 2000, what is the difference between the Production index(2004-2006) of Cameroon and Production index(2004-2006) of Micronesia?
Provide a short and direct response. -11.16. In the year 2000, what is the difference between the Production index(2004-2006) of Ethiopia and Production index(2004-2006) of Faeroe Islands?
Provide a succinct answer. -32.72. In the year 2000, what is the difference between the Production index(2004-2006) of Ethiopia and Production index(2004-2006) of Micronesia?
Provide a short and direct response. -18.94. In the year 2000, what is the difference between the Production index(2004-2006) in Faeroe Islands and Production index(2004-2006) in Micronesia?
Keep it short and to the point. 13.78. In the year 2001, what is the difference between the Production index(2004-2006) in Cameroon and Production index(2004-2006) in Ethiopia?
Ensure brevity in your answer.  2.71. In the year 2001, what is the difference between the Production index(2004-2006) of Cameroon and Production index(2004-2006) of Faeroe Islands?
Offer a terse response. -22.01. In the year 2001, what is the difference between the Production index(2004-2006) of Cameroon and Production index(2004-2006) of Micronesia?
Give a very brief answer. -12.55. In the year 2001, what is the difference between the Production index(2004-2006) of Ethiopia and Production index(2004-2006) of Faeroe Islands?
Give a very brief answer. -24.72. In the year 2001, what is the difference between the Production index(2004-2006) of Ethiopia and Production index(2004-2006) of Micronesia?
Give a very brief answer. -15.26. In the year 2001, what is the difference between the Production index(2004-2006) of Faeroe Islands and Production index(2004-2006) of Micronesia?
Provide a short and direct response. 9.46. In the year 2002, what is the difference between the Production index(2004-2006) in Cameroon and Production index(2004-2006) in Ethiopia?
Your answer should be very brief. -3.56. In the year 2002, what is the difference between the Production index(2004-2006) in Cameroon and Production index(2004-2006) in Faeroe Islands?
Give a very brief answer. -20.82. In the year 2002, what is the difference between the Production index(2004-2006) of Cameroon and Production index(2004-2006) of Micronesia?
Offer a very short reply. -11.13. In the year 2002, what is the difference between the Production index(2004-2006) of Ethiopia and Production index(2004-2006) of Faeroe Islands?
Your answer should be compact. -17.26. In the year 2002, what is the difference between the Production index(2004-2006) in Ethiopia and Production index(2004-2006) in Micronesia?
Offer a very short reply. -7.57. In the year 2002, what is the difference between the Production index(2004-2006) in Faeroe Islands and Production index(2004-2006) in Micronesia?
Provide a short and direct response. 9.69. What is the ratio of the Production index(2004-2006) of Cameroon in 1995 to that in 1996?
Your response must be concise. 0.95. What is the ratio of the Production index(2004-2006) in Ethiopia in 1995 to that in 1996?
Your answer should be very brief. 0.85. What is the ratio of the Production index(2004-2006) in Micronesia in 1995 to that in 1996?
Ensure brevity in your answer.  0.89. What is the ratio of the Production index(2004-2006) in Ethiopia in 1995 to that in 1997?
Make the answer very short. 0.84. What is the ratio of the Production index(2004-2006) of Faeroe Islands in 1995 to that in 1997?
Your answer should be compact. 0.99. What is the ratio of the Production index(2004-2006) of Micronesia in 1995 to that in 1997?
Keep it short and to the point. 0.89. What is the ratio of the Production index(2004-2006) of Cameroon in 1995 to that in 1998?
Provide a succinct answer. 0.94. What is the ratio of the Production index(2004-2006) of Ethiopia in 1995 to that in 1998?
Give a very brief answer. 0.91. What is the ratio of the Production index(2004-2006) of Micronesia in 1995 to that in 1998?
Offer a terse response. 0.89. What is the ratio of the Production index(2004-2006) in Cameroon in 1995 to that in 1999?
Ensure brevity in your answer.  0.9. What is the ratio of the Production index(2004-2006) in Ethiopia in 1995 to that in 1999?
Offer a terse response. 0.84. What is the ratio of the Production index(2004-2006) of Faeroe Islands in 1995 to that in 1999?
Provide a succinct answer. 1. What is the ratio of the Production index(2004-2006) in Micronesia in 1995 to that in 1999?
Make the answer very short. 0.98. What is the ratio of the Production index(2004-2006) of Cameroon in 1995 to that in 2000?
Your response must be concise. 0.88. What is the ratio of the Production index(2004-2006) of Ethiopia in 1995 to that in 2000?
Offer a very short reply. 0.82. What is the ratio of the Production index(2004-2006) in Cameroon in 1995 to that in 2001?
Provide a short and direct response. 0.86. What is the ratio of the Production index(2004-2006) of Ethiopia in 1995 to that in 2001?
Provide a short and direct response. 0.75. What is the ratio of the Production index(2004-2006) in Faeroe Islands in 1995 to that in 2001?
Your answer should be compact. 1.01. What is the ratio of the Production index(2004-2006) of Micronesia in 1995 to that in 2001?
Give a very brief answer. 0.93. What is the ratio of the Production index(2004-2006) of Cameroon in 1995 to that in 2002?
Provide a short and direct response. 0.84. What is the ratio of the Production index(2004-2006) of Ethiopia in 1995 to that in 2002?
Offer a very short reply. 0.67. What is the ratio of the Production index(2004-2006) of Micronesia in 1995 to that in 2002?
Your answer should be compact. 0.93. What is the ratio of the Production index(2004-2006) of Cameroon in 1996 to that in 1997?
Keep it short and to the point. 1.03. What is the ratio of the Production index(2004-2006) in Ethiopia in 1996 to that in 1997?
Your response must be concise. 0.98. What is the ratio of the Production index(2004-2006) of Faeroe Islands in 1996 to that in 1997?
Your answer should be compact. 1. What is the ratio of the Production index(2004-2006) in Cameroon in 1996 to that in 1998?
Give a very brief answer. 0.99. What is the ratio of the Production index(2004-2006) in Ethiopia in 1996 to that in 1998?
Give a very brief answer. 1.07. What is the ratio of the Production index(2004-2006) of Faeroe Islands in 1996 to that in 1998?
Give a very brief answer. 1.01. What is the ratio of the Production index(2004-2006) in Cameroon in 1996 to that in 1999?
Provide a succinct answer. 0.94. What is the ratio of the Production index(2004-2006) of Ethiopia in 1996 to that in 1999?
Offer a very short reply. 0.99. What is the ratio of the Production index(2004-2006) of Faeroe Islands in 1996 to that in 1999?
Provide a short and direct response. 1.01. What is the ratio of the Production index(2004-2006) in Micronesia in 1996 to that in 1999?
Your answer should be compact. 1.1. What is the ratio of the Production index(2004-2006) of Cameroon in 1996 to that in 2000?
Your answer should be very brief. 0.92. What is the ratio of the Production index(2004-2006) in Ethiopia in 1996 to that in 2000?
Provide a succinct answer. 0.96. What is the ratio of the Production index(2004-2006) in Faeroe Islands in 1996 to that in 2000?
Make the answer very short. 1.01. What is the ratio of the Production index(2004-2006) of Micronesia in 1996 to that in 2000?
Your answer should be compact. 1.09. What is the ratio of the Production index(2004-2006) of Cameroon in 1996 to that in 2001?
Offer a very short reply. 0.9. What is the ratio of the Production index(2004-2006) in Ethiopia in 1996 to that in 2001?
Offer a very short reply. 0.87. What is the ratio of the Production index(2004-2006) of Faeroe Islands in 1996 to that in 2001?
Make the answer very short. 1.02. What is the ratio of the Production index(2004-2006) of Micronesia in 1996 to that in 2001?
Offer a terse response. 1.05. What is the ratio of the Production index(2004-2006) of Cameroon in 1996 to that in 2002?
Give a very brief answer. 0.88. What is the ratio of the Production index(2004-2006) in Ethiopia in 1996 to that in 2002?
Offer a very short reply. 0.79. What is the ratio of the Production index(2004-2006) in Faeroe Islands in 1996 to that in 2002?
Offer a terse response. 1.01. What is the ratio of the Production index(2004-2006) in Micronesia in 1996 to that in 2002?
Give a very brief answer. 1.04. What is the ratio of the Production index(2004-2006) in Cameroon in 1997 to that in 1998?
Provide a succinct answer. 0.95. What is the ratio of the Production index(2004-2006) of Ethiopia in 1997 to that in 1998?
Your answer should be very brief. 1.09. What is the ratio of the Production index(2004-2006) in Faeroe Islands in 1997 to that in 1998?
Your answer should be very brief. 1.01. What is the ratio of the Production index(2004-2006) in Micronesia in 1997 to that in 1998?
Keep it short and to the point. 1. What is the ratio of the Production index(2004-2006) of Cameroon in 1997 to that in 1999?
Provide a short and direct response. 0.91. What is the ratio of the Production index(2004-2006) of Ethiopia in 1997 to that in 1999?
Your answer should be compact. 1.01. What is the ratio of the Production index(2004-2006) in Faeroe Islands in 1997 to that in 1999?
Offer a very short reply. 1.01. What is the ratio of the Production index(2004-2006) in Micronesia in 1997 to that in 1999?
Your response must be concise. 1.1. What is the ratio of the Production index(2004-2006) in Cameroon in 1997 to that in 2000?
Your answer should be compact. 0.89. What is the ratio of the Production index(2004-2006) in Ethiopia in 1997 to that in 2000?
Your answer should be compact. 0.98. What is the ratio of the Production index(2004-2006) in Faeroe Islands in 1997 to that in 2000?
Keep it short and to the point. 1.01. What is the ratio of the Production index(2004-2006) in Micronesia in 1997 to that in 2000?
Give a very brief answer. 1.08. What is the ratio of the Production index(2004-2006) of Cameroon in 1997 to that in 2001?
Offer a terse response. 0.87. What is the ratio of the Production index(2004-2006) in Ethiopia in 1997 to that in 2001?
Keep it short and to the point. 0.89. What is the ratio of the Production index(2004-2006) in Micronesia in 1997 to that in 2001?
Offer a very short reply. 1.04. What is the ratio of the Production index(2004-2006) in Cameroon in 1997 to that in 2002?
Ensure brevity in your answer.  0.85. What is the ratio of the Production index(2004-2006) in Ethiopia in 1997 to that in 2002?
Your response must be concise. 0.8. What is the ratio of the Production index(2004-2006) of Faeroe Islands in 1997 to that in 2002?
Your answer should be very brief. 1.01. What is the ratio of the Production index(2004-2006) in Micronesia in 1997 to that in 2002?
Make the answer very short. 1.04. What is the ratio of the Production index(2004-2006) of Cameroon in 1998 to that in 1999?
Your answer should be compact. 0.96. What is the ratio of the Production index(2004-2006) in Ethiopia in 1998 to that in 1999?
Offer a very short reply. 0.93. What is the ratio of the Production index(2004-2006) in Faeroe Islands in 1998 to that in 1999?
Offer a terse response. 0.99. What is the ratio of the Production index(2004-2006) in Micronesia in 1998 to that in 1999?
Your response must be concise. 1.1. What is the ratio of the Production index(2004-2006) in Cameroon in 1998 to that in 2000?
Keep it short and to the point. 0.93. What is the ratio of the Production index(2004-2006) of Ethiopia in 1998 to that in 2000?
Keep it short and to the point. 0.9. What is the ratio of the Production index(2004-2006) of Micronesia in 1998 to that in 2000?
Provide a succinct answer. 1.08. What is the ratio of the Production index(2004-2006) of Cameroon in 1998 to that in 2001?
Give a very brief answer. 0.91. What is the ratio of the Production index(2004-2006) in Ethiopia in 1998 to that in 2001?
Provide a short and direct response. 0.82. What is the ratio of the Production index(2004-2006) of Faeroe Islands in 1998 to that in 2001?
Make the answer very short. 1.01. What is the ratio of the Production index(2004-2006) of Micronesia in 1998 to that in 2001?
Your response must be concise. 1.04. What is the ratio of the Production index(2004-2006) in Ethiopia in 1998 to that in 2002?
Provide a succinct answer. 0.74. What is the ratio of the Production index(2004-2006) in Micronesia in 1998 to that in 2002?
Your response must be concise. 1.04. What is the ratio of the Production index(2004-2006) in Cameroon in 1999 to that in 2000?
Ensure brevity in your answer.  0.98. What is the ratio of the Production index(2004-2006) of Ethiopia in 1999 to that in 2000?
Ensure brevity in your answer.  0.97. What is the ratio of the Production index(2004-2006) in Faeroe Islands in 1999 to that in 2000?
Provide a succinct answer. 1. What is the ratio of the Production index(2004-2006) of Micronesia in 1999 to that in 2000?
Your answer should be very brief. 0.99. What is the ratio of the Production index(2004-2006) of Cameroon in 1999 to that in 2001?
Offer a very short reply. 0.95. What is the ratio of the Production index(2004-2006) in Ethiopia in 1999 to that in 2001?
Your response must be concise. 0.88. What is the ratio of the Production index(2004-2006) in Micronesia in 1999 to that in 2001?
Keep it short and to the point. 0.95. What is the ratio of the Production index(2004-2006) of Cameroon in 1999 to that in 2002?
Give a very brief answer. 0.93. What is the ratio of the Production index(2004-2006) in Ethiopia in 1999 to that in 2002?
Provide a short and direct response. 0.8. What is the ratio of the Production index(2004-2006) of Micronesia in 1999 to that in 2002?
Provide a short and direct response. 0.95. What is the ratio of the Production index(2004-2006) in Cameroon in 2000 to that in 2001?
Provide a succinct answer. 0.98. What is the ratio of the Production index(2004-2006) of Ethiopia in 2000 to that in 2001?
Keep it short and to the point. 0.91. What is the ratio of the Production index(2004-2006) of Faeroe Islands in 2000 to that in 2001?
Give a very brief answer. 1.01. What is the ratio of the Production index(2004-2006) in Micronesia in 2000 to that in 2001?
Provide a succinct answer. 0.96. What is the ratio of the Production index(2004-2006) in Cameroon in 2000 to that in 2002?
Your answer should be very brief. 0.95. What is the ratio of the Production index(2004-2006) in Ethiopia in 2000 to that in 2002?
Your answer should be compact. 0.82. What is the ratio of the Production index(2004-2006) in Faeroe Islands in 2000 to that in 2002?
Your answer should be compact. 1. What is the ratio of the Production index(2004-2006) of Cameroon in 2001 to that in 2002?
Your response must be concise. 0.98. What is the ratio of the Production index(2004-2006) of Ethiopia in 2001 to that in 2002?
Give a very brief answer. 0.9. What is the ratio of the Production index(2004-2006) in Faeroe Islands in 2001 to that in 2002?
Provide a succinct answer. 0.99. What is the ratio of the Production index(2004-2006) of Micronesia in 2001 to that in 2002?
Keep it short and to the point. 0.99. What is the difference between the highest and the second highest Production index(2004-2006) of Cameroon?
Your answer should be compact. 2.02. What is the difference between the highest and the second highest Production index(2004-2006) of Ethiopia?
Your response must be concise. 8.29. What is the difference between the highest and the second highest Production index(2004-2006) in Faeroe Islands?
Give a very brief answer. 0.22. What is the difference between the highest and the second highest Production index(2004-2006) of Micronesia?
Your answer should be compact. 0.32. What is the difference between the highest and the lowest Production index(2004-2006) of Cameroon?
Make the answer very short. 13.39. What is the difference between the highest and the lowest Production index(2004-2006) of Ethiopia?
Ensure brevity in your answer.  27.77. What is the difference between the highest and the lowest Production index(2004-2006) in Faeroe Islands?
Give a very brief answer. 2.24. What is the difference between the highest and the lowest Production index(2004-2006) of Micronesia?
Your response must be concise. 10.63. 